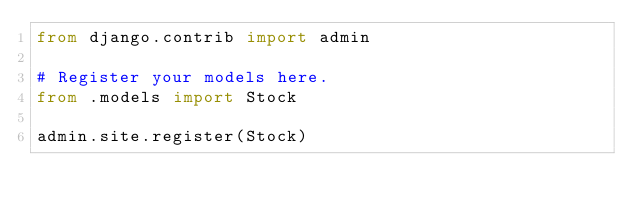Convert code to text. <code><loc_0><loc_0><loc_500><loc_500><_Python_>from django.contrib import admin

# Register your models here.
from .models import Stock

admin.site.register(Stock)
</code> 